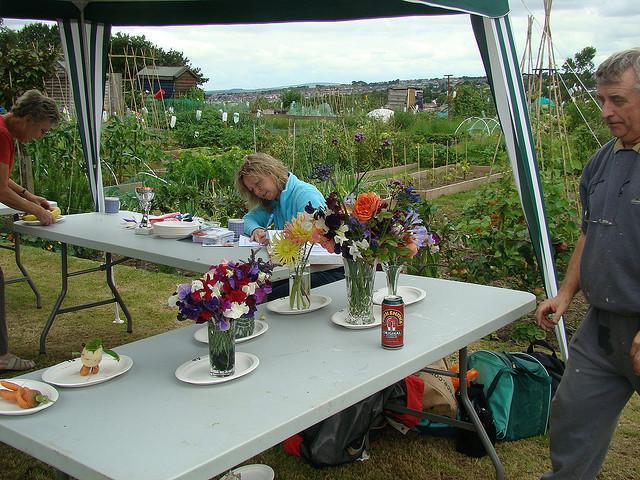How many vases are on the table?
Give a very brief answer. 5. How many tables are there?
Give a very brief answer. 2. How many backpacks are in the photo?
Give a very brief answer. 2. How many dining tables are visible?
Give a very brief answer. 2. How many people are there?
Give a very brief answer. 3. 